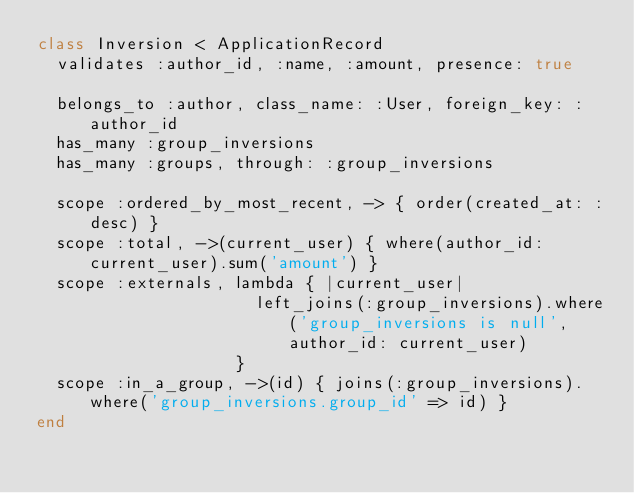<code> <loc_0><loc_0><loc_500><loc_500><_Ruby_>class Inversion < ApplicationRecord
  validates :author_id, :name, :amount, presence: true

  belongs_to :author, class_name: :User, foreign_key: :author_id
  has_many :group_inversions
  has_many :groups, through: :group_inversions

  scope :ordered_by_most_recent, -> { order(created_at: :desc) }
  scope :total, ->(current_user) { where(author_id: current_user).sum('amount') }
  scope :externals, lambda { |current_user|
                      left_joins(:group_inversions).where('group_inversions is null', author_id: current_user)
                    }
  scope :in_a_group, ->(id) { joins(:group_inversions).where('group_inversions.group_id' => id) }
end
</code> 